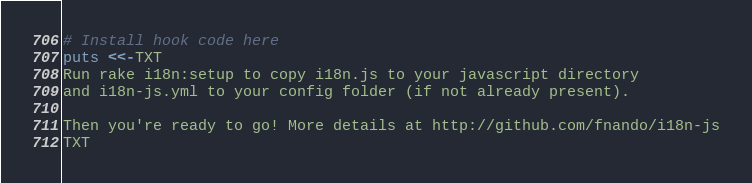Convert code to text. <code><loc_0><loc_0><loc_500><loc_500><_Ruby_># Install hook code here
puts <<-TXT
Run rake i18n:setup to copy i18n.js to your javascript directory
and i18n-js.yml to your config folder (if not already present).

Then you're ready to go! More details at http://github.com/fnando/i18n-js
TXT
</code> 